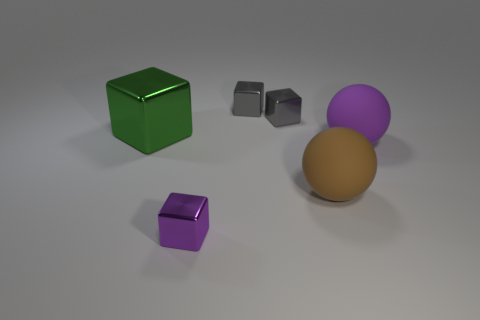Can you describe the positions of the different objects in relation to each other? Certainly! In the center of the image, there are two spheres, one purple and one brown, close to each other, creating a sense of grouping. The green cube is positioned to the right of these spheres, with sufficient space separating them, suggesting a contrast or distinction. To the far left, there is a smaller purple cube set apart from the rest, emphasizing its isolation. 